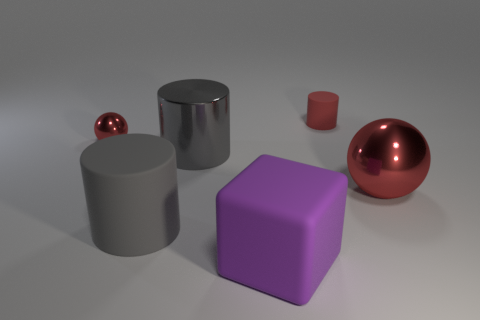Are there the same number of large gray matte cylinders that are left of the big gray matte object and red metallic balls on the right side of the big red thing?
Keep it short and to the point. Yes. What size is the sphere on the right side of the big purple rubber thing?
Provide a succinct answer. Large. Is the tiny cylinder the same color as the tiny shiny thing?
Provide a succinct answer. Yes. Is there any other thing that is the same shape as the large purple matte thing?
Offer a very short reply. No. There is a cylinder that is the same color as the tiny ball; what material is it?
Keep it short and to the point. Rubber. Is the number of tiny shiny objects in front of the big sphere the same as the number of large red metal spheres?
Keep it short and to the point. No. Are there any gray matte cylinders on the left side of the small red metallic thing?
Your answer should be very brief. No. There is a large red shiny thing; is it the same shape as the rubber object behind the big red shiny ball?
Offer a very short reply. No. What is the color of the large sphere that is the same material as the tiny red ball?
Your answer should be very brief. Red. The large metal ball has what color?
Ensure brevity in your answer.  Red. 